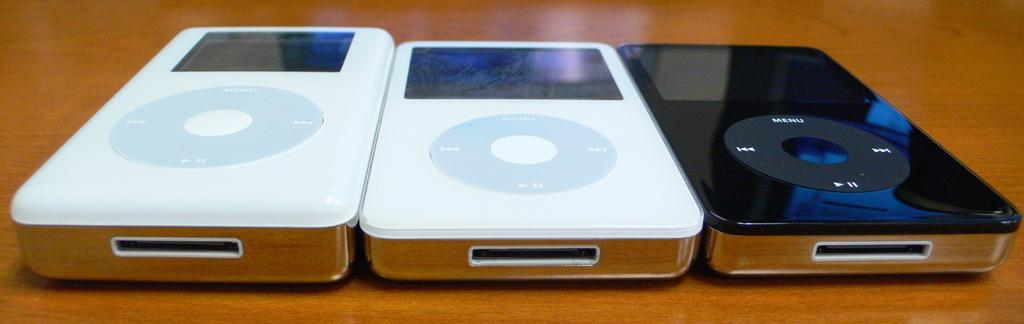What type of objects can be seen in the image? There are electronic objects in the image. What colors are the electronic objects? The electronic objects are white and black in color. What is the color of the surface in the image? The surface is brown in color. Can you hear any noise coming from the electronic objects in the image? There is no information about noise in the image, as it only provides visual information about the electronic objects and their colors. 